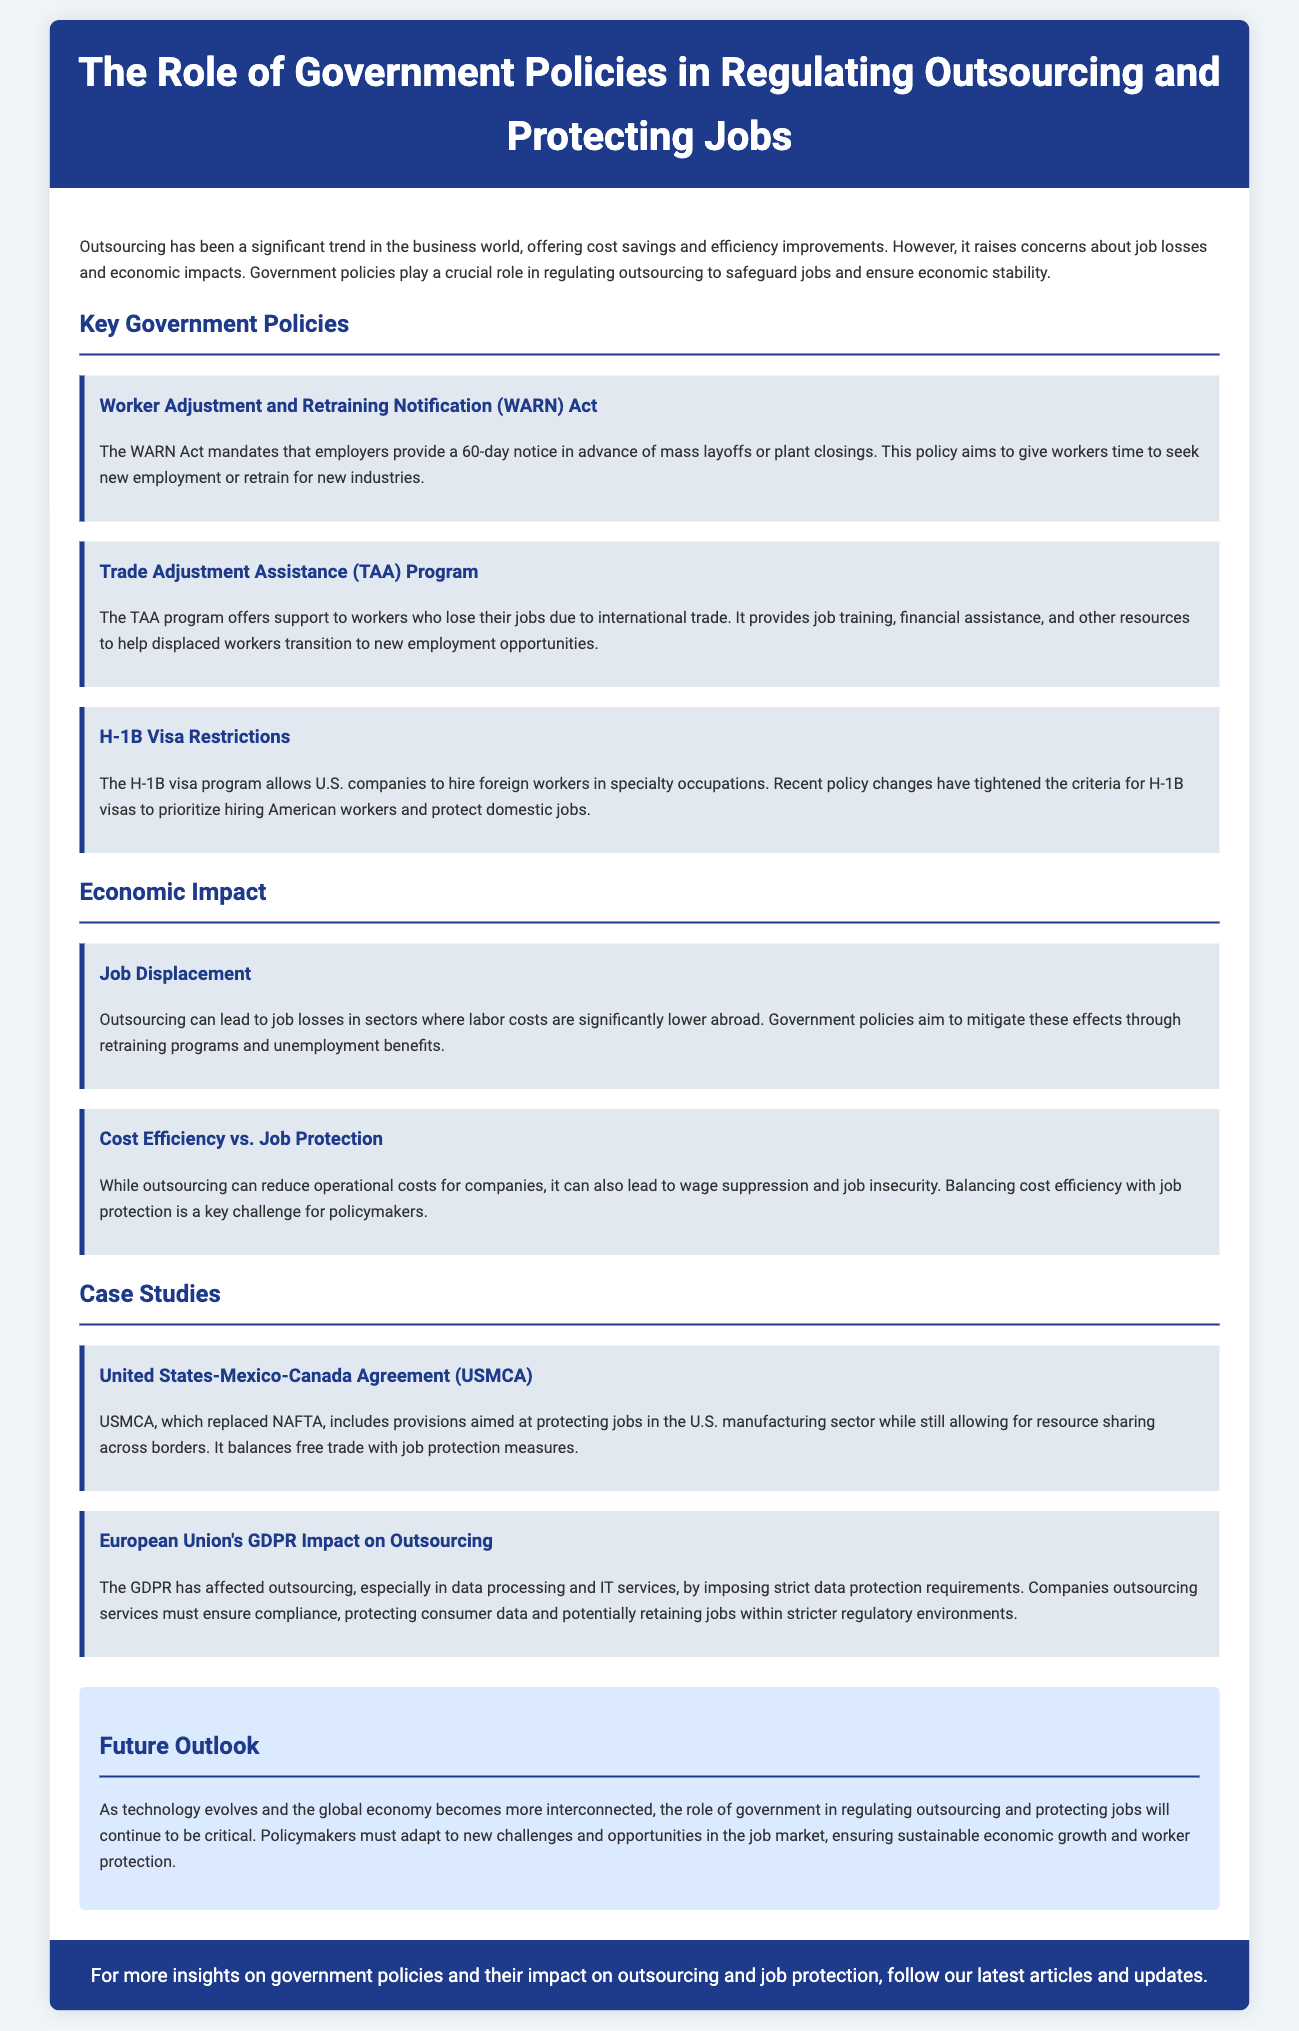What is the purpose of the WARN Act? The WARN Act aims to give workers time to seek new employment or retrain for new industries by mandating a 60-day notice for mass layoffs or plant closings.
Answer: To give workers time to seek new employment or retrain What does the TAA program provide to displaced workers? The TAA program offers job training, financial assistance, and other resources to help workers transition to new employment opportunities.
Answer: Job training, financial assistance, and resources What recent changes have been made to the H-1B visa program? Recent policy changes have tightened the criteria for H-1B visas to prioritize hiring American workers and protect domestic jobs.
Answer: Tightened criteria to prioritize hiring American workers What economic effect does outsourcing have on job displacement? Outsourcing can lead to job losses in sectors where labor costs are significantly lower abroad.
Answer: Job losses in lower labor cost sectors What is a key challenge for policymakers regarding outsourcing? Balancing cost efficiency with job protection is a key challenge for policymakers.
Answer: Balancing cost efficiency with job protection What agreement replaced NAFTA? The United States-Mexico-Canada Agreement (USMCA) replaced NAFTA.
Answer: United States-Mexico-Canada Agreement (USMCA) How does GDPR impact outsourcing, according to the document? GDPR imposes strict data protection requirements that companies must comply with when outsourcing services.
Answer: It imposes strict data protection requirements What does the future outlook section emphasize? The future outlook emphasizes the critical role of government in regulating outsourcing and protecting jobs.
Answer: The critical role of government in regulating outsourcing 